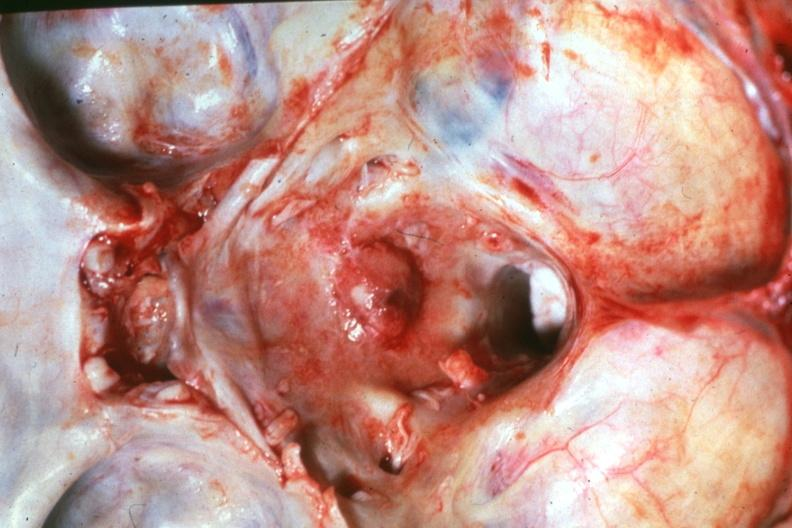s bone, calvarium present?
Answer the question using a single word or phrase. Yes 